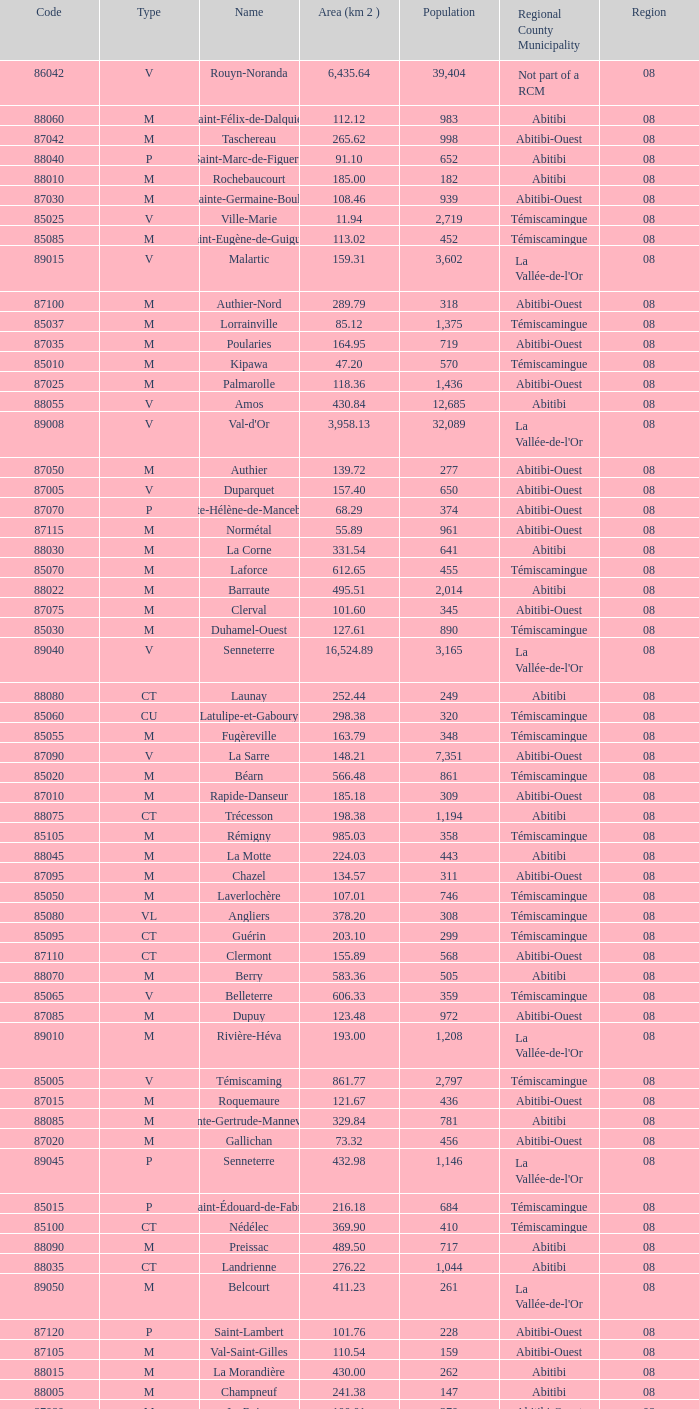What municipality has 719 people and is larger than 108.46 km2? Abitibi-Ouest. 